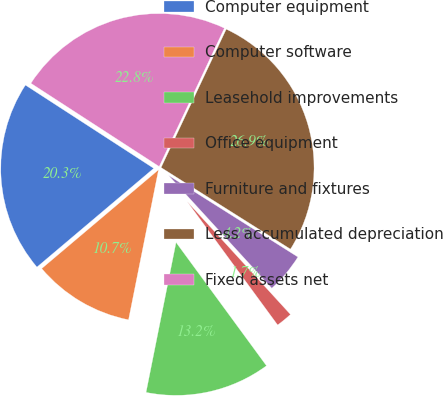Convert chart to OTSL. <chart><loc_0><loc_0><loc_500><loc_500><pie_chart><fcel>Computer equipment<fcel>Computer software<fcel>Leasehold improvements<fcel>Office equipment<fcel>Furniture and fixtures<fcel>Less accumulated depreciation<fcel>Fixed assets net<nl><fcel>20.33%<fcel>10.69%<fcel>13.21%<fcel>1.73%<fcel>4.25%<fcel>26.95%<fcel>22.85%<nl></chart> 